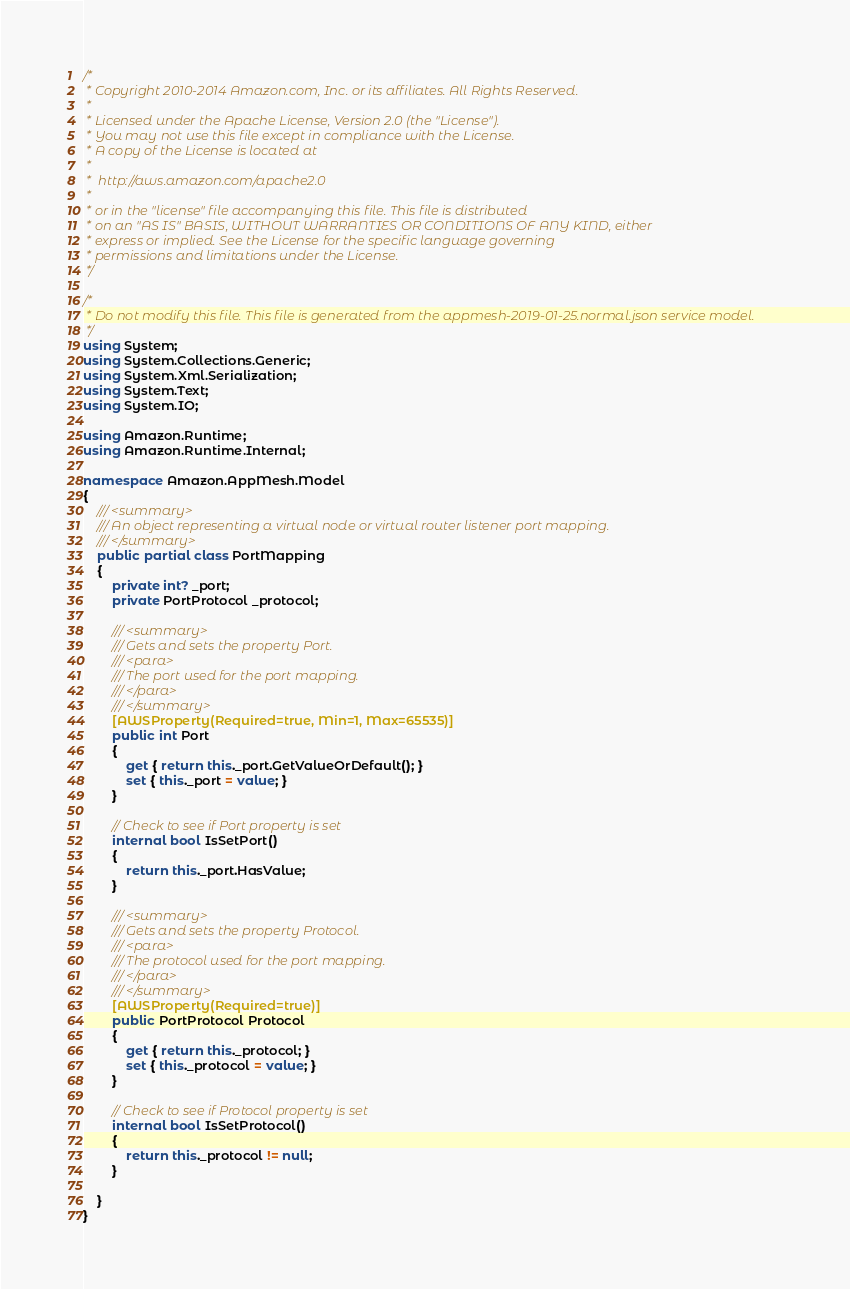<code> <loc_0><loc_0><loc_500><loc_500><_C#_>/*
 * Copyright 2010-2014 Amazon.com, Inc. or its affiliates. All Rights Reserved.
 * 
 * Licensed under the Apache License, Version 2.0 (the "License").
 * You may not use this file except in compliance with the License.
 * A copy of the License is located at
 * 
 *  http://aws.amazon.com/apache2.0
 * 
 * or in the "license" file accompanying this file. This file is distributed
 * on an "AS IS" BASIS, WITHOUT WARRANTIES OR CONDITIONS OF ANY KIND, either
 * express or implied. See the License for the specific language governing
 * permissions and limitations under the License.
 */

/*
 * Do not modify this file. This file is generated from the appmesh-2019-01-25.normal.json service model.
 */
using System;
using System.Collections.Generic;
using System.Xml.Serialization;
using System.Text;
using System.IO;

using Amazon.Runtime;
using Amazon.Runtime.Internal;

namespace Amazon.AppMesh.Model
{
    /// <summary>
    /// An object representing a virtual node or virtual router listener port mapping.
    /// </summary>
    public partial class PortMapping
    {
        private int? _port;
        private PortProtocol _protocol;

        /// <summary>
        /// Gets and sets the property Port. 
        /// <para>
        /// The port used for the port mapping.
        /// </para>
        /// </summary>
        [AWSProperty(Required=true, Min=1, Max=65535)]
        public int Port
        {
            get { return this._port.GetValueOrDefault(); }
            set { this._port = value; }
        }

        // Check to see if Port property is set
        internal bool IsSetPort()
        {
            return this._port.HasValue; 
        }

        /// <summary>
        /// Gets and sets the property Protocol. 
        /// <para>
        /// The protocol used for the port mapping.
        /// </para>
        /// </summary>
        [AWSProperty(Required=true)]
        public PortProtocol Protocol
        {
            get { return this._protocol; }
            set { this._protocol = value; }
        }

        // Check to see if Protocol property is set
        internal bool IsSetProtocol()
        {
            return this._protocol != null;
        }

    }
}</code> 